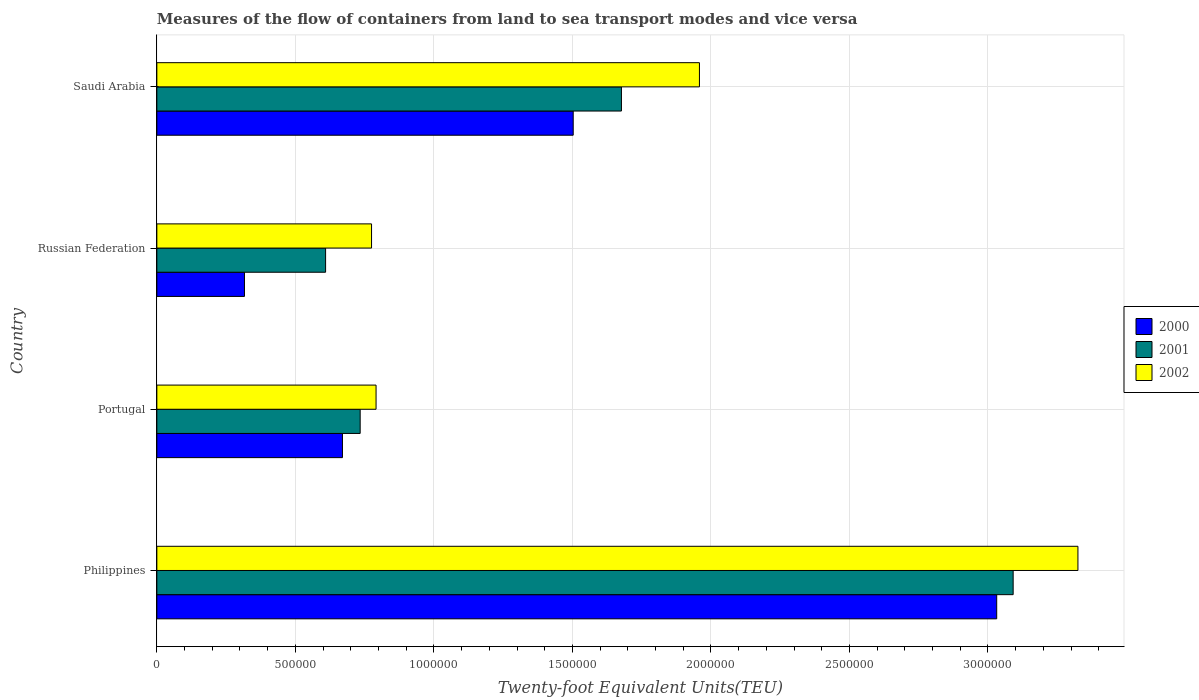Are the number of bars on each tick of the Y-axis equal?
Offer a terse response. Yes. How many bars are there on the 2nd tick from the top?
Provide a succinct answer. 3. How many bars are there on the 1st tick from the bottom?
Keep it short and to the point. 3. What is the label of the 3rd group of bars from the top?
Provide a short and direct response. Portugal. What is the container port traffic in 2001 in Philippines?
Your response must be concise. 3.09e+06. Across all countries, what is the maximum container port traffic in 2002?
Make the answer very short. 3.32e+06. Across all countries, what is the minimum container port traffic in 2000?
Provide a short and direct response. 3.16e+05. In which country was the container port traffic in 2001 maximum?
Provide a succinct answer. Philippines. In which country was the container port traffic in 2000 minimum?
Offer a very short reply. Russian Federation. What is the total container port traffic in 2002 in the graph?
Make the answer very short. 6.85e+06. What is the difference between the container port traffic in 2002 in Philippines and that in Russian Federation?
Ensure brevity in your answer.  2.55e+06. What is the difference between the container port traffic in 2001 in Saudi Arabia and the container port traffic in 2000 in Philippines?
Provide a succinct answer. -1.35e+06. What is the average container port traffic in 2001 per country?
Provide a short and direct response. 1.53e+06. What is the difference between the container port traffic in 2001 and container port traffic in 2002 in Philippines?
Provide a short and direct response. -2.34e+05. What is the ratio of the container port traffic in 2000 in Portugal to that in Russian Federation?
Offer a terse response. 2.12. What is the difference between the highest and the second highest container port traffic in 2002?
Offer a terse response. 1.37e+06. What is the difference between the highest and the lowest container port traffic in 2001?
Your answer should be compact. 2.48e+06. In how many countries, is the container port traffic in 2001 greater than the average container port traffic in 2001 taken over all countries?
Ensure brevity in your answer.  2. Is the sum of the container port traffic in 2002 in Portugal and Saudi Arabia greater than the maximum container port traffic in 2001 across all countries?
Provide a succinct answer. No. What does the 3rd bar from the top in Saudi Arabia represents?
Give a very brief answer. 2000. Is it the case that in every country, the sum of the container port traffic in 2001 and container port traffic in 2000 is greater than the container port traffic in 2002?
Your answer should be compact. Yes. Are all the bars in the graph horizontal?
Ensure brevity in your answer.  Yes. Are the values on the major ticks of X-axis written in scientific E-notation?
Offer a terse response. No. Does the graph contain grids?
Offer a very short reply. Yes. Where does the legend appear in the graph?
Keep it short and to the point. Center right. What is the title of the graph?
Your answer should be compact. Measures of the flow of containers from land to sea transport modes and vice versa. Does "2011" appear as one of the legend labels in the graph?
Ensure brevity in your answer.  No. What is the label or title of the X-axis?
Provide a succinct answer. Twenty-foot Equivalent Units(TEU). What is the label or title of the Y-axis?
Your answer should be very brief. Country. What is the Twenty-foot Equivalent Units(TEU) of 2000 in Philippines?
Your answer should be very brief. 3.03e+06. What is the Twenty-foot Equivalent Units(TEU) of 2001 in Philippines?
Your answer should be very brief. 3.09e+06. What is the Twenty-foot Equivalent Units(TEU) of 2002 in Philippines?
Give a very brief answer. 3.32e+06. What is the Twenty-foot Equivalent Units(TEU) in 2000 in Portugal?
Offer a terse response. 6.70e+05. What is the Twenty-foot Equivalent Units(TEU) of 2001 in Portugal?
Offer a terse response. 7.34e+05. What is the Twenty-foot Equivalent Units(TEU) of 2002 in Portugal?
Offer a very short reply. 7.91e+05. What is the Twenty-foot Equivalent Units(TEU) of 2000 in Russian Federation?
Make the answer very short. 3.16e+05. What is the Twenty-foot Equivalent Units(TEU) in 2001 in Russian Federation?
Your response must be concise. 6.09e+05. What is the Twenty-foot Equivalent Units(TEU) of 2002 in Russian Federation?
Your response must be concise. 7.75e+05. What is the Twenty-foot Equivalent Units(TEU) in 2000 in Saudi Arabia?
Your answer should be compact. 1.50e+06. What is the Twenty-foot Equivalent Units(TEU) of 2001 in Saudi Arabia?
Make the answer very short. 1.68e+06. What is the Twenty-foot Equivalent Units(TEU) in 2002 in Saudi Arabia?
Give a very brief answer. 1.96e+06. Across all countries, what is the maximum Twenty-foot Equivalent Units(TEU) in 2000?
Give a very brief answer. 3.03e+06. Across all countries, what is the maximum Twenty-foot Equivalent Units(TEU) of 2001?
Your response must be concise. 3.09e+06. Across all countries, what is the maximum Twenty-foot Equivalent Units(TEU) of 2002?
Ensure brevity in your answer.  3.32e+06. Across all countries, what is the minimum Twenty-foot Equivalent Units(TEU) in 2000?
Ensure brevity in your answer.  3.16e+05. Across all countries, what is the minimum Twenty-foot Equivalent Units(TEU) of 2001?
Your answer should be compact. 6.09e+05. Across all countries, what is the minimum Twenty-foot Equivalent Units(TEU) in 2002?
Your answer should be compact. 7.75e+05. What is the total Twenty-foot Equivalent Units(TEU) in 2000 in the graph?
Provide a short and direct response. 5.52e+06. What is the total Twenty-foot Equivalent Units(TEU) of 2001 in the graph?
Provide a short and direct response. 6.11e+06. What is the total Twenty-foot Equivalent Units(TEU) in 2002 in the graph?
Keep it short and to the point. 6.85e+06. What is the difference between the Twenty-foot Equivalent Units(TEU) of 2000 in Philippines and that in Portugal?
Ensure brevity in your answer.  2.36e+06. What is the difference between the Twenty-foot Equivalent Units(TEU) of 2001 in Philippines and that in Portugal?
Your answer should be very brief. 2.36e+06. What is the difference between the Twenty-foot Equivalent Units(TEU) of 2002 in Philippines and that in Portugal?
Ensure brevity in your answer.  2.53e+06. What is the difference between the Twenty-foot Equivalent Units(TEU) in 2000 in Philippines and that in Russian Federation?
Offer a very short reply. 2.72e+06. What is the difference between the Twenty-foot Equivalent Units(TEU) of 2001 in Philippines and that in Russian Federation?
Provide a succinct answer. 2.48e+06. What is the difference between the Twenty-foot Equivalent Units(TEU) of 2002 in Philippines and that in Russian Federation?
Offer a very short reply. 2.55e+06. What is the difference between the Twenty-foot Equivalent Units(TEU) of 2000 in Philippines and that in Saudi Arabia?
Provide a succinct answer. 1.53e+06. What is the difference between the Twenty-foot Equivalent Units(TEU) in 2001 in Philippines and that in Saudi Arabia?
Make the answer very short. 1.41e+06. What is the difference between the Twenty-foot Equivalent Units(TEU) in 2002 in Philippines and that in Saudi Arabia?
Make the answer very short. 1.37e+06. What is the difference between the Twenty-foot Equivalent Units(TEU) in 2000 in Portugal and that in Russian Federation?
Ensure brevity in your answer.  3.54e+05. What is the difference between the Twenty-foot Equivalent Units(TEU) in 2001 in Portugal and that in Russian Federation?
Your answer should be compact. 1.25e+05. What is the difference between the Twenty-foot Equivalent Units(TEU) in 2002 in Portugal and that in Russian Federation?
Provide a succinct answer. 1.63e+04. What is the difference between the Twenty-foot Equivalent Units(TEU) in 2000 in Portugal and that in Saudi Arabia?
Your answer should be compact. -8.33e+05. What is the difference between the Twenty-foot Equivalent Units(TEU) in 2001 in Portugal and that in Saudi Arabia?
Offer a very short reply. -9.43e+05. What is the difference between the Twenty-foot Equivalent Units(TEU) of 2002 in Portugal and that in Saudi Arabia?
Offer a terse response. -1.17e+06. What is the difference between the Twenty-foot Equivalent Units(TEU) of 2000 in Russian Federation and that in Saudi Arabia?
Ensure brevity in your answer.  -1.19e+06. What is the difference between the Twenty-foot Equivalent Units(TEU) of 2001 in Russian Federation and that in Saudi Arabia?
Your answer should be compact. -1.07e+06. What is the difference between the Twenty-foot Equivalent Units(TEU) of 2002 in Russian Federation and that in Saudi Arabia?
Offer a terse response. -1.18e+06. What is the difference between the Twenty-foot Equivalent Units(TEU) in 2000 in Philippines and the Twenty-foot Equivalent Units(TEU) in 2001 in Portugal?
Your response must be concise. 2.30e+06. What is the difference between the Twenty-foot Equivalent Units(TEU) of 2000 in Philippines and the Twenty-foot Equivalent Units(TEU) of 2002 in Portugal?
Your answer should be very brief. 2.24e+06. What is the difference between the Twenty-foot Equivalent Units(TEU) of 2001 in Philippines and the Twenty-foot Equivalent Units(TEU) of 2002 in Portugal?
Give a very brief answer. 2.30e+06. What is the difference between the Twenty-foot Equivalent Units(TEU) of 2000 in Philippines and the Twenty-foot Equivalent Units(TEU) of 2001 in Russian Federation?
Give a very brief answer. 2.42e+06. What is the difference between the Twenty-foot Equivalent Units(TEU) of 2000 in Philippines and the Twenty-foot Equivalent Units(TEU) of 2002 in Russian Federation?
Ensure brevity in your answer.  2.26e+06. What is the difference between the Twenty-foot Equivalent Units(TEU) in 2001 in Philippines and the Twenty-foot Equivalent Units(TEU) in 2002 in Russian Federation?
Provide a succinct answer. 2.32e+06. What is the difference between the Twenty-foot Equivalent Units(TEU) in 2000 in Philippines and the Twenty-foot Equivalent Units(TEU) in 2001 in Saudi Arabia?
Offer a terse response. 1.35e+06. What is the difference between the Twenty-foot Equivalent Units(TEU) in 2000 in Philippines and the Twenty-foot Equivalent Units(TEU) in 2002 in Saudi Arabia?
Offer a terse response. 1.07e+06. What is the difference between the Twenty-foot Equivalent Units(TEU) in 2001 in Philippines and the Twenty-foot Equivalent Units(TEU) in 2002 in Saudi Arabia?
Offer a very short reply. 1.13e+06. What is the difference between the Twenty-foot Equivalent Units(TEU) of 2000 in Portugal and the Twenty-foot Equivalent Units(TEU) of 2001 in Russian Federation?
Offer a very short reply. 6.09e+04. What is the difference between the Twenty-foot Equivalent Units(TEU) in 2000 in Portugal and the Twenty-foot Equivalent Units(TEU) in 2002 in Russian Federation?
Your response must be concise. -1.05e+05. What is the difference between the Twenty-foot Equivalent Units(TEU) of 2001 in Portugal and the Twenty-foot Equivalent Units(TEU) of 2002 in Russian Federation?
Your answer should be compact. -4.10e+04. What is the difference between the Twenty-foot Equivalent Units(TEU) in 2000 in Portugal and the Twenty-foot Equivalent Units(TEU) in 2001 in Saudi Arabia?
Provide a short and direct response. -1.01e+06. What is the difference between the Twenty-foot Equivalent Units(TEU) in 2000 in Portugal and the Twenty-foot Equivalent Units(TEU) in 2002 in Saudi Arabia?
Ensure brevity in your answer.  -1.29e+06. What is the difference between the Twenty-foot Equivalent Units(TEU) of 2001 in Portugal and the Twenty-foot Equivalent Units(TEU) of 2002 in Saudi Arabia?
Keep it short and to the point. -1.22e+06. What is the difference between the Twenty-foot Equivalent Units(TEU) of 2000 in Russian Federation and the Twenty-foot Equivalent Units(TEU) of 2001 in Saudi Arabia?
Give a very brief answer. -1.36e+06. What is the difference between the Twenty-foot Equivalent Units(TEU) of 2000 in Russian Federation and the Twenty-foot Equivalent Units(TEU) of 2002 in Saudi Arabia?
Offer a terse response. -1.64e+06. What is the difference between the Twenty-foot Equivalent Units(TEU) in 2001 in Russian Federation and the Twenty-foot Equivalent Units(TEU) in 2002 in Saudi Arabia?
Your response must be concise. -1.35e+06. What is the average Twenty-foot Equivalent Units(TEU) in 2000 per country?
Offer a terse response. 1.38e+06. What is the average Twenty-foot Equivalent Units(TEU) in 2001 per country?
Ensure brevity in your answer.  1.53e+06. What is the average Twenty-foot Equivalent Units(TEU) of 2002 per country?
Your answer should be very brief. 1.71e+06. What is the difference between the Twenty-foot Equivalent Units(TEU) of 2000 and Twenty-foot Equivalent Units(TEU) of 2001 in Philippines?
Provide a short and direct response. -5.94e+04. What is the difference between the Twenty-foot Equivalent Units(TEU) of 2000 and Twenty-foot Equivalent Units(TEU) of 2002 in Philippines?
Your answer should be compact. -2.93e+05. What is the difference between the Twenty-foot Equivalent Units(TEU) of 2001 and Twenty-foot Equivalent Units(TEU) of 2002 in Philippines?
Your response must be concise. -2.34e+05. What is the difference between the Twenty-foot Equivalent Units(TEU) in 2000 and Twenty-foot Equivalent Units(TEU) in 2001 in Portugal?
Keep it short and to the point. -6.40e+04. What is the difference between the Twenty-foot Equivalent Units(TEU) in 2000 and Twenty-foot Equivalent Units(TEU) in 2002 in Portugal?
Offer a terse response. -1.21e+05. What is the difference between the Twenty-foot Equivalent Units(TEU) of 2001 and Twenty-foot Equivalent Units(TEU) of 2002 in Portugal?
Your answer should be very brief. -5.74e+04. What is the difference between the Twenty-foot Equivalent Units(TEU) in 2000 and Twenty-foot Equivalent Units(TEU) in 2001 in Russian Federation?
Make the answer very short. -2.93e+05. What is the difference between the Twenty-foot Equivalent Units(TEU) of 2000 and Twenty-foot Equivalent Units(TEU) of 2002 in Russian Federation?
Keep it short and to the point. -4.59e+05. What is the difference between the Twenty-foot Equivalent Units(TEU) in 2001 and Twenty-foot Equivalent Units(TEU) in 2002 in Russian Federation?
Your answer should be compact. -1.66e+05. What is the difference between the Twenty-foot Equivalent Units(TEU) in 2000 and Twenty-foot Equivalent Units(TEU) in 2001 in Saudi Arabia?
Provide a succinct answer. -1.74e+05. What is the difference between the Twenty-foot Equivalent Units(TEU) of 2000 and Twenty-foot Equivalent Units(TEU) of 2002 in Saudi Arabia?
Your answer should be very brief. -4.56e+05. What is the difference between the Twenty-foot Equivalent Units(TEU) in 2001 and Twenty-foot Equivalent Units(TEU) in 2002 in Saudi Arabia?
Ensure brevity in your answer.  -2.82e+05. What is the ratio of the Twenty-foot Equivalent Units(TEU) in 2000 in Philippines to that in Portugal?
Provide a short and direct response. 4.52. What is the ratio of the Twenty-foot Equivalent Units(TEU) in 2001 in Philippines to that in Portugal?
Provide a succinct answer. 4.21. What is the ratio of the Twenty-foot Equivalent Units(TEU) in 2002 in Philippines to that in Portugal?
Provide a short and direct response. 4.2. What is the ratio of the Twenty-foot Equivalent Units(TEU) of 2000 in Philippines to that in Russian Federation?
Provide a short and direct response. 9.59. What is the ratio of the Twenty-foot Equivalent Units(TEU) in 2001 in Philippines to that in Russian Federation?
Your answer should be very brief. 5.07. What is the ratio of the Twenty-foot Equivalent Units(TEU) of 2002 in Philippines to that in Russian Federation?
Provide a short and direct response. 4.29. What is the ratio of the Twenty-foot Equivalent Units(TEU) in 2000 in Philippines to that in Saudi Arabia?
Your answer should be very brief. 2.02. What is the ratio of the Twenty-foot Equivalent Units(TEU) in 2001 in Philippines to that in Saudi Arabia?
Provide a succinct answer. 1.84. What is the ratio of the Twenty-foot Equivalent Units(TEU) in 2002 in Philippines to that in Saudi Arabia?
Your answer should be very brief. 1.7. What is the ratio of the Twenty-foot Equivalent Units(TEU) in 2000 in Portugal to that in Russian Federation?
Offer a terse response. 2.12. What is the ratio of the Twenty-foot Equivalent Units(TEU) of 2001 in Portugal to that in Russian Federation?
Make the answer very short. 1.21. What is the ratio of the Twenty-foot Equivalent Units(TEU) in 2002 in Portugal to that in Russian Federation?
Provide a succinct answer. 1.02. What is the ratio of the Twenty-foot Equivalent Units(TEU) in 2000 in Portugal to that in Saudi Arabia?
Keep it short and to the point. 0.45. What is the ratio of the Twenty-foot Equivalent Units(TEU) in 2001 in Portugal to that in Saudi Arabia?
Make the answer very short. 0.44. What is the ratio of the Twenty-foot Equivalent Units(TEU) of 2002 in Portugal to that in Saudi Arabia?
Provide a succinct answer. 0.4. What is the ratio of the Twenty-foot Equivalent Units(TEU) of 2000 in Russian Federation to that in Saudi Arabia?
Make the answer very short. 0.21. What is the ratio of the Twenty-foot Equivalent Units(TEU) of 2001 in Russian Federation to that in Saudi Arabia?
Your response must be concise. 0.36. What is the ratio of the Twenty-foot Equivalent Units(TEU) of 2002 in Russian Federation to that in Saudi Arabia?
Provide a short and direct response. 0.4. What is the difference between the highest and the second highest Twenty-foot Equivalent Units(TEU) of 2000?
Your answer should be very brief. 1.53e+06. What is the difference between the highest and the second highest Twenty-foot Equivalent Units(TEU) of 2001?
Provide a short and direct response. 1.41e+06. What is the difference between the highest and the second highest Twenty-foot Equivalent Units(TEU) of 2002?
Offer a terse response. 1.37e+06. What is the difference between the highest and the lowest Twenty-foot Equivalent Units(TEU) of 2000?
Your answer should be very brief. 2.72e+06. What is the difference between the highest and the lowest Twenty-foot Equivalent Units(TEU) in 2001?
Your answer should be compact. 2.48e+06. What is the difference between the highest and the lowest Twenty-foot Equivalent Units(TEU) of 2002?
Keep it short and to the point. 2.55e+06. 